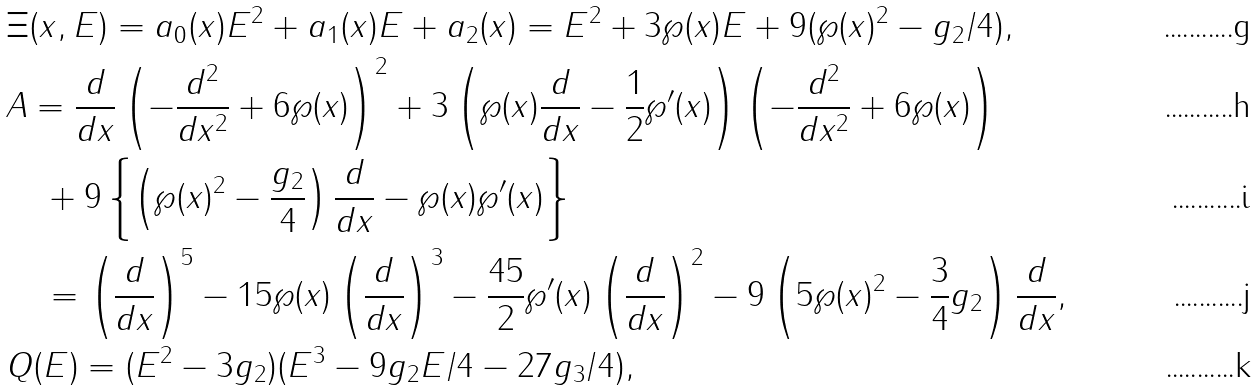<formula> <loc_0><loc_0><loc_500><loc_500>& \Xi ( x , E ) = a _ { 0 } ( x ) E ^ { 2 } + a _ { 1 } ( x ) E + a _ { 2 } ( x ) = E ^ { 2 } + 3 \wp ( x ) E + 9 ( \wp ( x ) ^ { 2 } - g _ { 2 } / 4 ) , \\ & A = \frac { d } { d x } \left ( - \frac { d ^ { 2 } } { d x ^ { 2 } } + 6 \wp ( x ) \right ) ^ { 2 } + 3 \left ( \wp ( x ) \frac { d } { d x } - \frac { 1 } { 2 } \wp ^ { \prime } ( x ) \right ) \left ( - \frac { d ^ { 2 } } { d x ^ { 2 } } + 6 \wp ( x ) \right ) \\ & \quad + 9 \left \{ \left ( \wp ( x ) ^ { 2 } - \frac { g _ { 2 } } { 4 } \right ) \frac { d } { d x } - \wp ( x ) \wp ^ { \prime } ( x ) \right \} \\ & \quad = \left ( \frac { d } { d x } \right ) ^ { 5 } - 1 5 \wp ( x ) \left ( \frac { d } { d x } \right ) ^ { 3 } - \frac { 4 5 } { 2 } \wp ^ { \prime } ( x ) \left ( \frac { d } { d x } \right ) ^ { 2 } - 9 \left ( 5 \wp ( x ) ^ { 2 } - \frac { 3 } { 4 } g _ { 2 } \right ) \frac { d } { d x } , \\ & Q ( E ) = ( E ^ { 2 } - 3 g _ { 2 } ) ( E ^ { 3 } - 9 g _ { 2 } E / 4 - 2 7 g _ { 3 } / 4 ) ,</formula> 